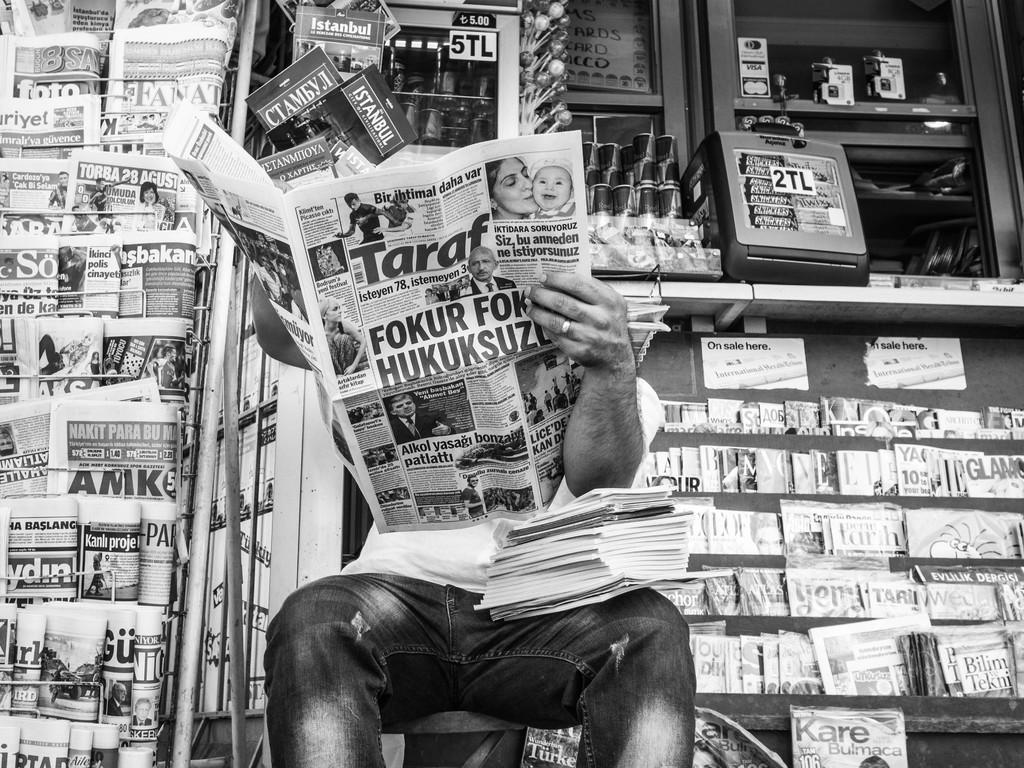Can you describe this image briefly? This is a black and white image. In the center of the image there is a person sitting and reading a newspaper. In the background of the image there are many books and newspapers arranged in a rack. 